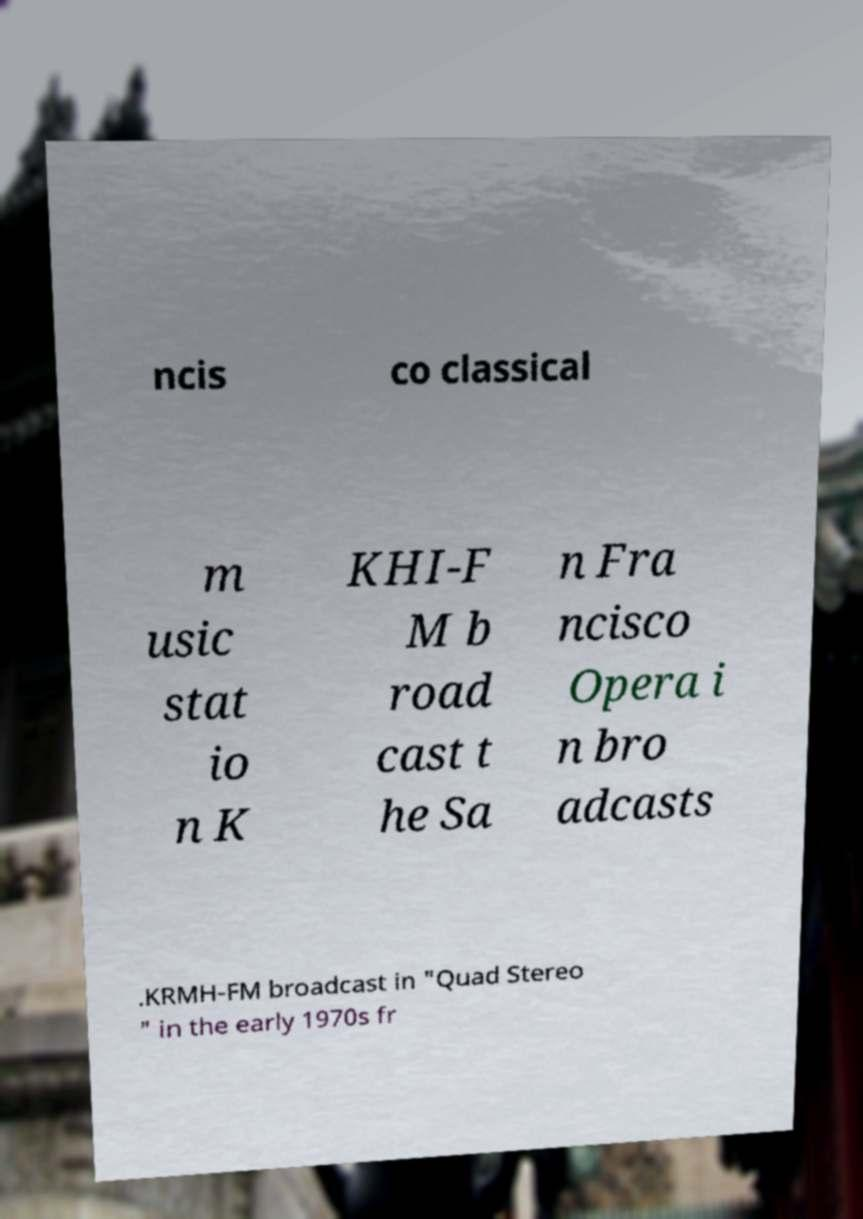I need the written content from this picture converted into text. Can you do that? ncis co classical m usic stat io n K KHI-F M b road cast t he Sa n Fra ncisco Opera i n bro adcasts .KRMH-FM broadcast in "Quad Stereo " in the early 1970s fr 